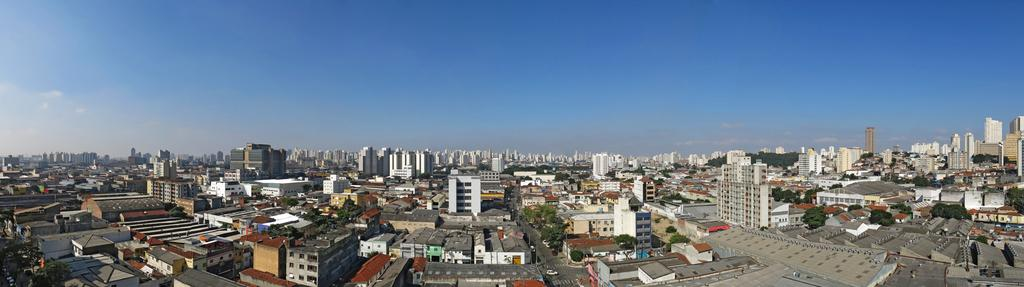What type of structures can be seen in the image? There are buildings in the image. What other natural elements are present in the image? There are trees in the image. What can be seen in the sky in the image? There are clouds in the image. What type of lettuce is being used as a decoration on the buildings in the image? There is no lettuce present in the image, as it features buildings, trees, and clouds. 